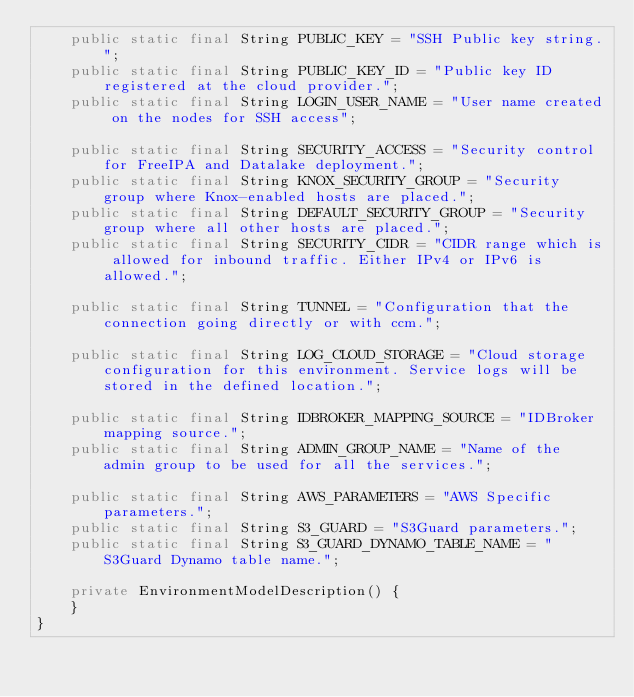Convert code to text. <code><loc_0><loc_0><loc_500><loc_500><_Java_>    public static final String PUBLIC_KEY = "SSH Public key string.";
    public static final String PUBLIC_KEY_ID = "Public key ID registered at the cloud provider.";
    public static final String LOGIN_USER_NAME = "User name created on the nodes for SSH access";

    public static final String SECURITY_ACCESS = "Security control for FreeIPA and Datalake deployment.";
    public static final String KNOX_SECURITY_GROUP = "Security group where Knox-enabled hosts are placed.";
    public static final String DEFAULT_SECURITY_GROUP = "Security group where all other hosts are placed.";
    public static final String SECURITY_CIDR = "CIDR range which is allowed for inbound traffic. Either IPv4 or IPv6 is allowed.";

    public static final String TUNNEL = "Configuration that the connection going directly or with ccm.";

    public static final String LOG_CLOUD_STORAGE = "Cloud storage configuration for this environment. Service logs will be stored in the defined location.";

    public static final String IDBROKER_MAPPING_SOURCE = "IDBroker mapping source.";
    public static final String ADMIN_GROUP_NAME = "Name of the admin group to be used for all the services.";

    public static final String AWS_PARAMETERS = "AWS Specific parameters.";
    public static final String S3_GUARD = "S3Guard parameters.";
    public static final String S3_GUARD_DYNAMO_TABLE_NAME = "S3Guard Dynamo table name.";

    private EnvironmentModelDescription() {
    }
}
</code> 